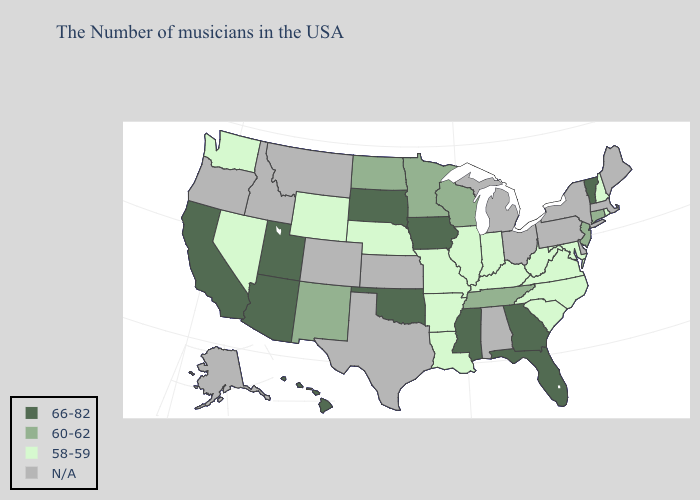Name the states that have a value in the range 58-59?
Be succinct. Rhode Island, New Hampshire, Maryland, Virginia, North Carolina, South Carolina, West Virginia, Kentucky, Indiana, Illinois, Louisiana, Missouri, Arkansas, Nebraska, Wyoming, Nevada, Washington. Does Tennessee have the highest value in the USA?
Be succinct. No. What is the highest value in the West ?
Answer briefly. 66-82. What is the highest value in the South ?
Give a very brief answer. 66-82. What is the lowest value in the West?
Be succinct. 58-59. Which states have the highest value in the USA?
Concise answer only. Vermont, Florida, Georgia, Mississippi, Iowa, Oklahoma, South Dakota, Utah, Arizona, California, Hawaii. Does New Hampshire have the lowest value in the Northeast?
Short answer required. Yes. What is the highest value in the USA?
Give a very brief answer. 66-82. Name the states that have a value in the range 58-59?
Write a very short answer. Rhode Island, New Hampshire, Maryland, Virginia, North Carolina, South Carolina, West Virginia, Kentucky, Indiana, Illinois, Louisiana, Missouri, Arkansas, Nebraska, Wyoming, Nevada, Washington. Name the states that have a value in the range 66-82?
Concise answer only. Vermont, Florida, Georgia, Mississippi, Iowa, Oklahoma, South Dakota, Utah, Arizona, California, Hawaii. Does Missouri have the lowest value in the USA?
Concise answer only. Yes. What is the value of Arizona?
Quick response, please. 66-82. Name the states that have a value in the range 66-82?
Write a very short answer. Vermont, Florida, Georgia, Mississippi, Iowa, Oklahoma, South Dakota, Utah, Arizona, California, Hawaii. Does the map have missing data?
Keep it brief. Yes. 